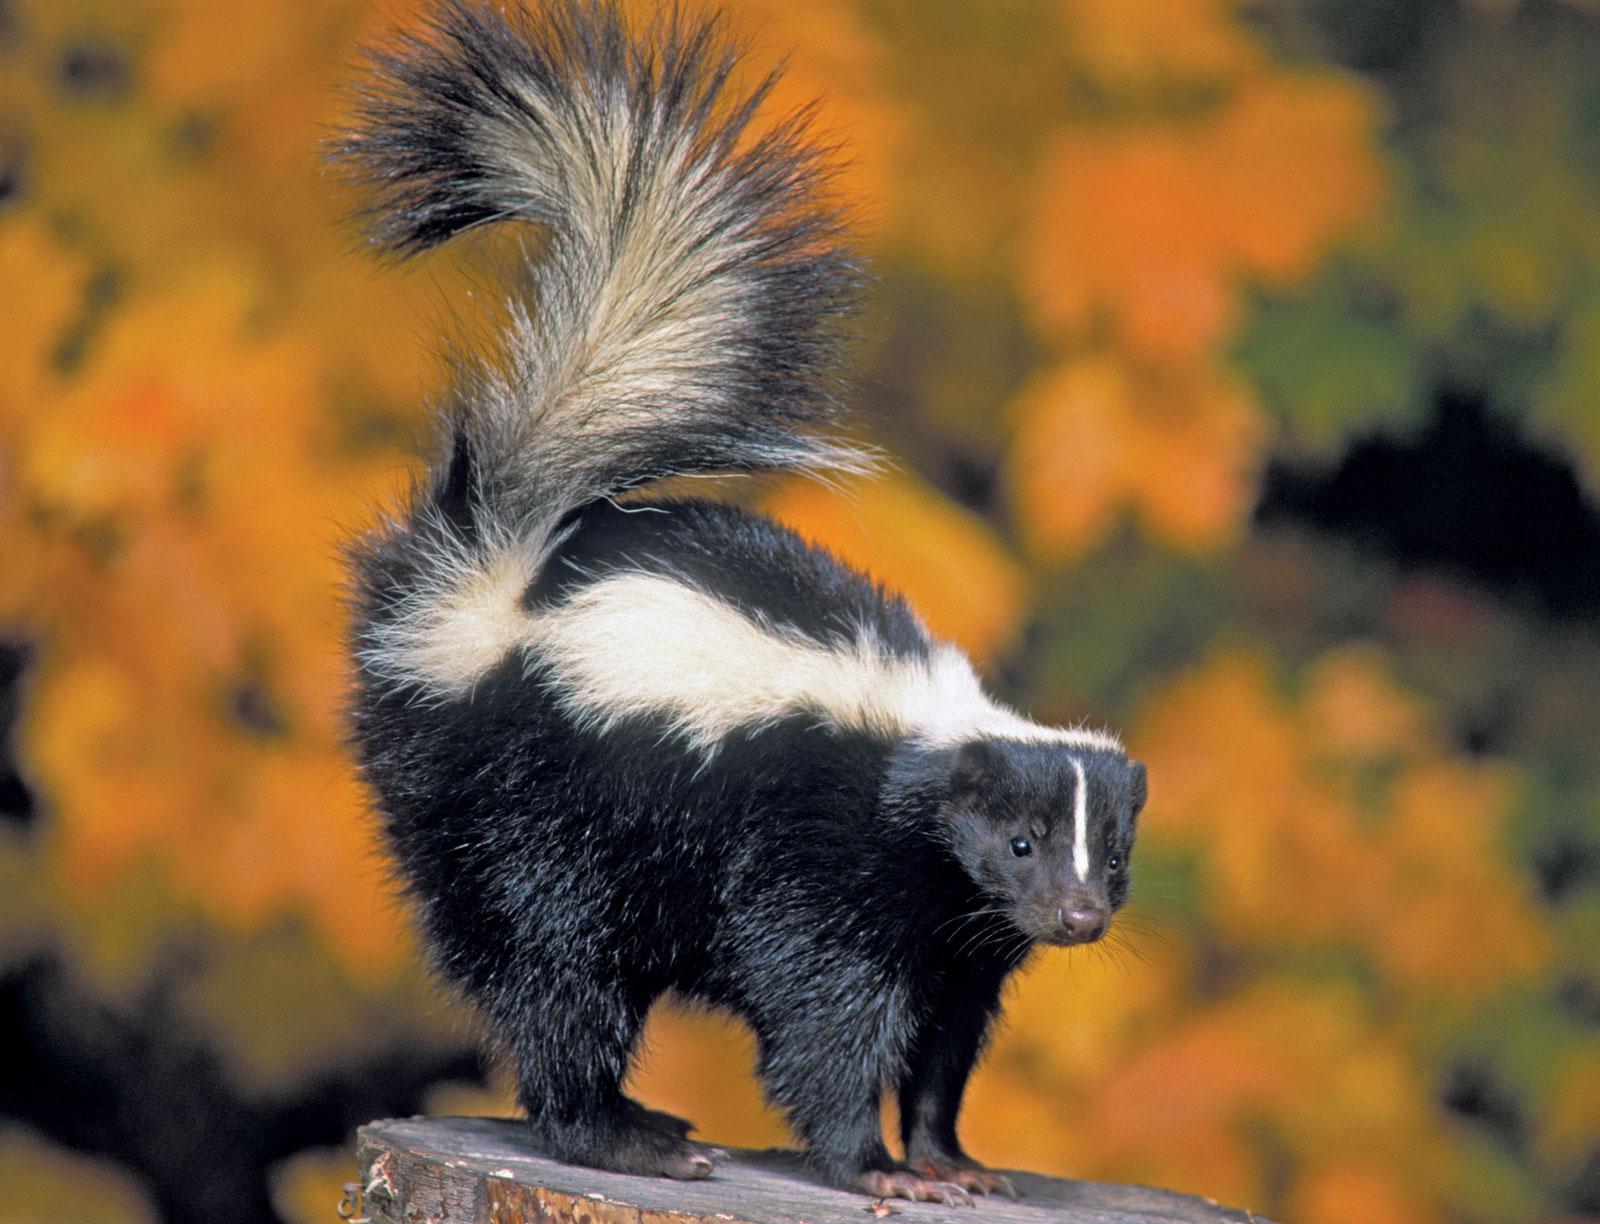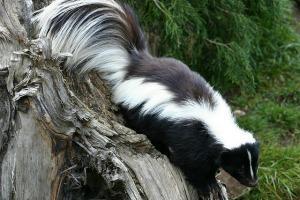The first image is the image on the left, the second image is the image on the right. For the images shown, is this caption "In the image to the left, the skunk is standing among some green grass." true? Answer yes or no. No. The first image is the image on the left, the second image is the image on the right. For the images displayed, is the sentence "All skunks are standing with their bodies in profile and all skunks have their bodies turned in the same direction." factually correct? Answer yes or no. Yes. 